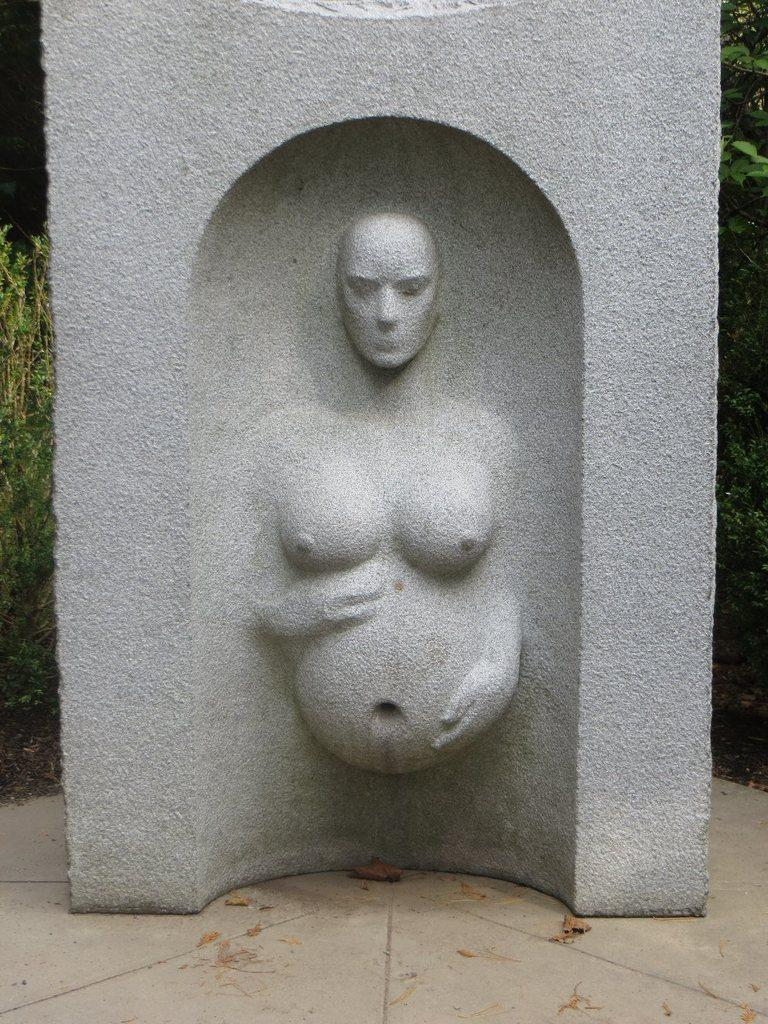What is depicted on the stone in the image? There is a sculpture on the stone in the image. Where is the stone located in the image? The stone is on the floor in the image. What can be seen in the background of the image? There are plants in the background of the image. How many cushions are placed around the stone in the image? There are no cushions present in the image. What type of tools might a carpenter use to create the sculpture on the stone? The image does not show any tools or the process of creating the sculpture, so it is not possible to determine what tools a carpenter might use. 